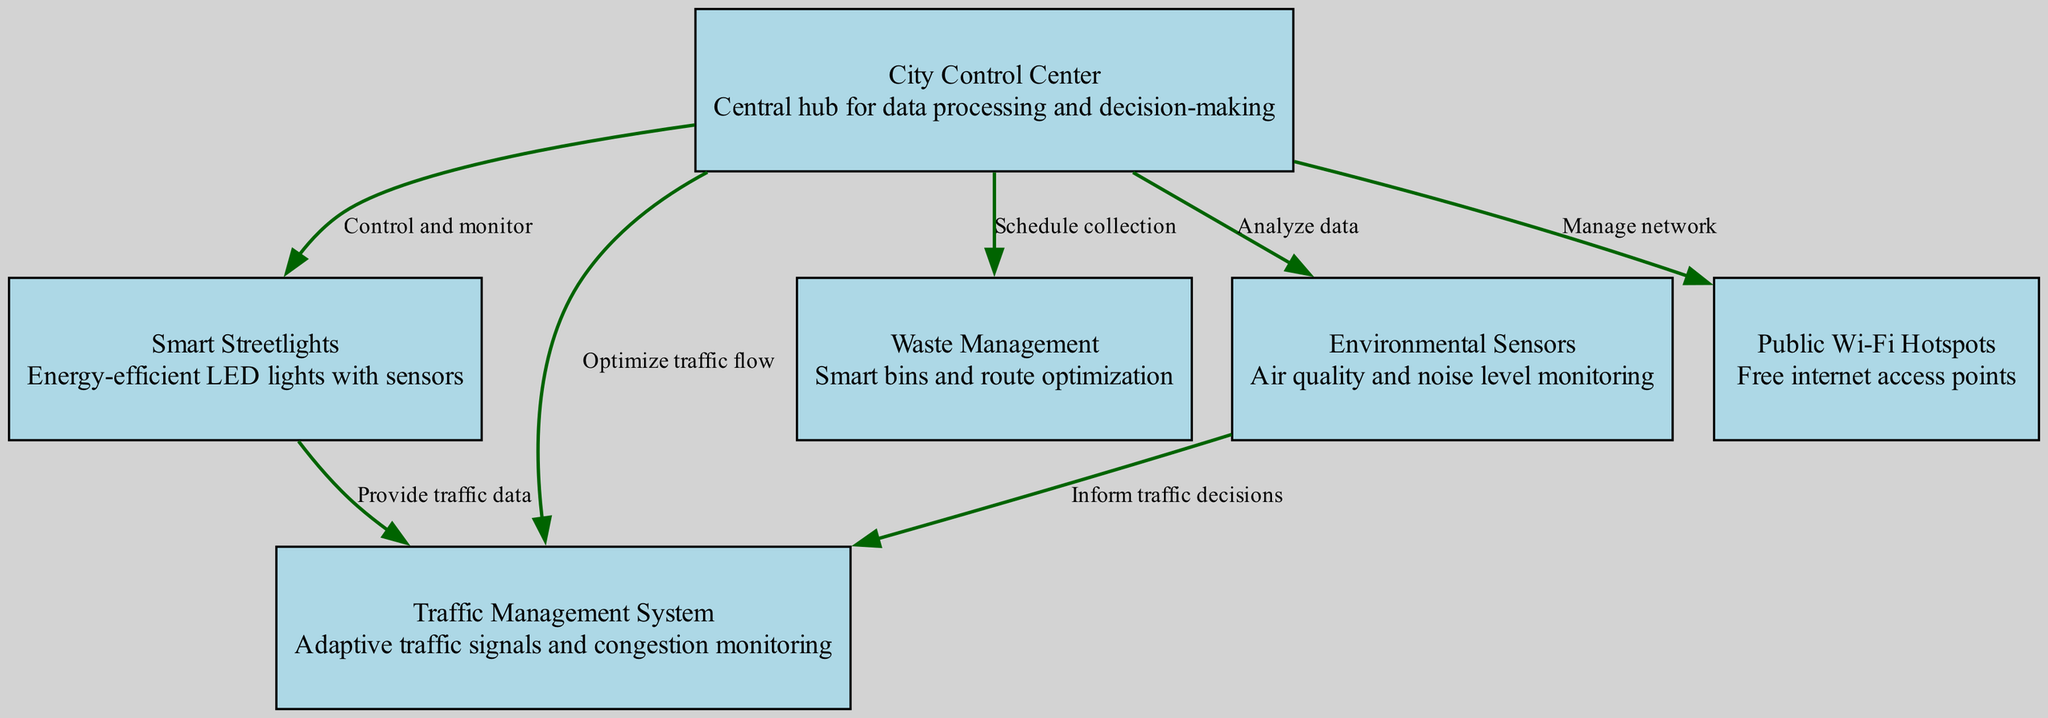What is the central node of the diagram? The central hub, or node, of the diagram is identified as the "City Control Center," which serves as the main control point for data processing and decision-making.
Answer: City Control Center How many nodes are present in the diagram? By counting each distinct node included in the data set, we find that there are six separate nodes.
Answer: 6 What type of data is provided by Smart Streetlights to the Traffic Management System? The Smart Streetlights are noted for providing traffic data, which is crucial for the Traffic Management System to function effectively.
Answer: Traffic data What is the relationship between Environmental Sensors and Traffic Management System? The Environmental Sensors inform the Traffic Management System by providing data that helps inform traffic decisions, establishing a direct relationship between the two systems.
Answer: Inform traffic decisions Which node is responsible for scheduling collection in waste management? The node identified for scheduling collection in waste management is the "City Control Center," which oversees the waste management function efficiently.
Answer: City Control Center How many edges connect the City Control Center to other nodes? The City Control Center has direct connections, or edges, to five other nodes, indicating its central role in managing various systems.
Answer: 5 Which node monitors air quality and noise levels? The node designated for monitoring air quality and noise levels is labeled as "Environmental Sensors," essential for urban health and sustainability.
Answer: Environmental Sensors What is the primary function of Public Wi-Fi Hotspots in the network? The primary function of the Public Wi-Fi Hotspots is to provide free internet access points throughout the city, enhancing connectivity for citizens.
Answer: Free internet access points Which component of the infrastructure is focused on energy efficiency? The component that emphasizes energy efficiency among the nodes is the "Smart Streetlights," designed to use energy-efficient LED technology.
Answer: Smart Streetlights 